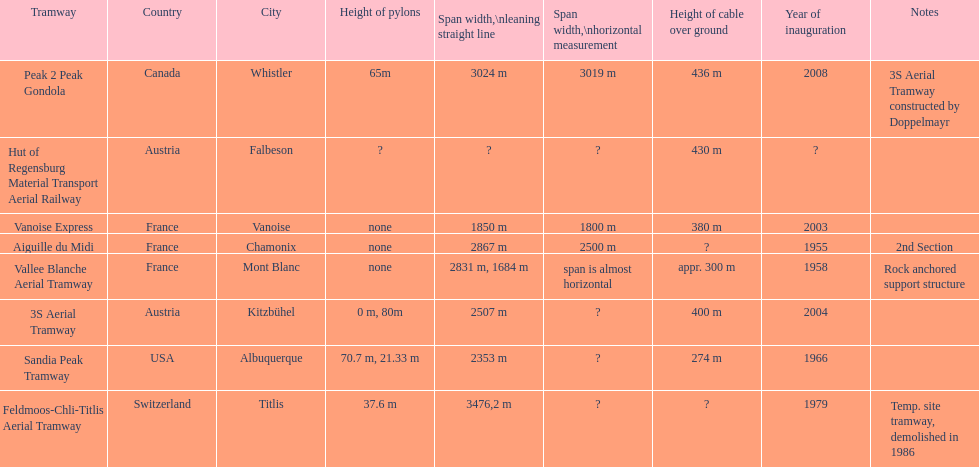Was the sandia peak tramway innagurate before or after the 3s aerial tramway? Before. 